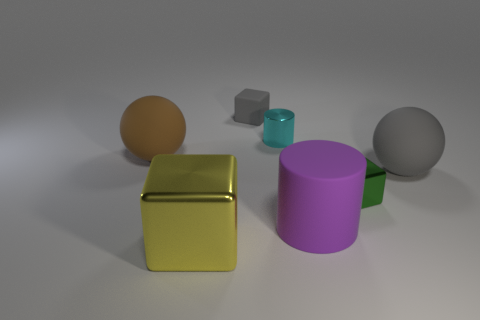Add 1 large purple cylinders. How many objects exist? 8 Subtract all spheres. How many objects are left? 5 Add 3 large brown objects. How many large brown objects are left? 4 Add 5 red spheres. How many red spheres exist? 5 Subtract 0 brown blocks. How many objects are left? 7 Subtract all cylinders. Subtract all brown objects. How many objects are left? 4 